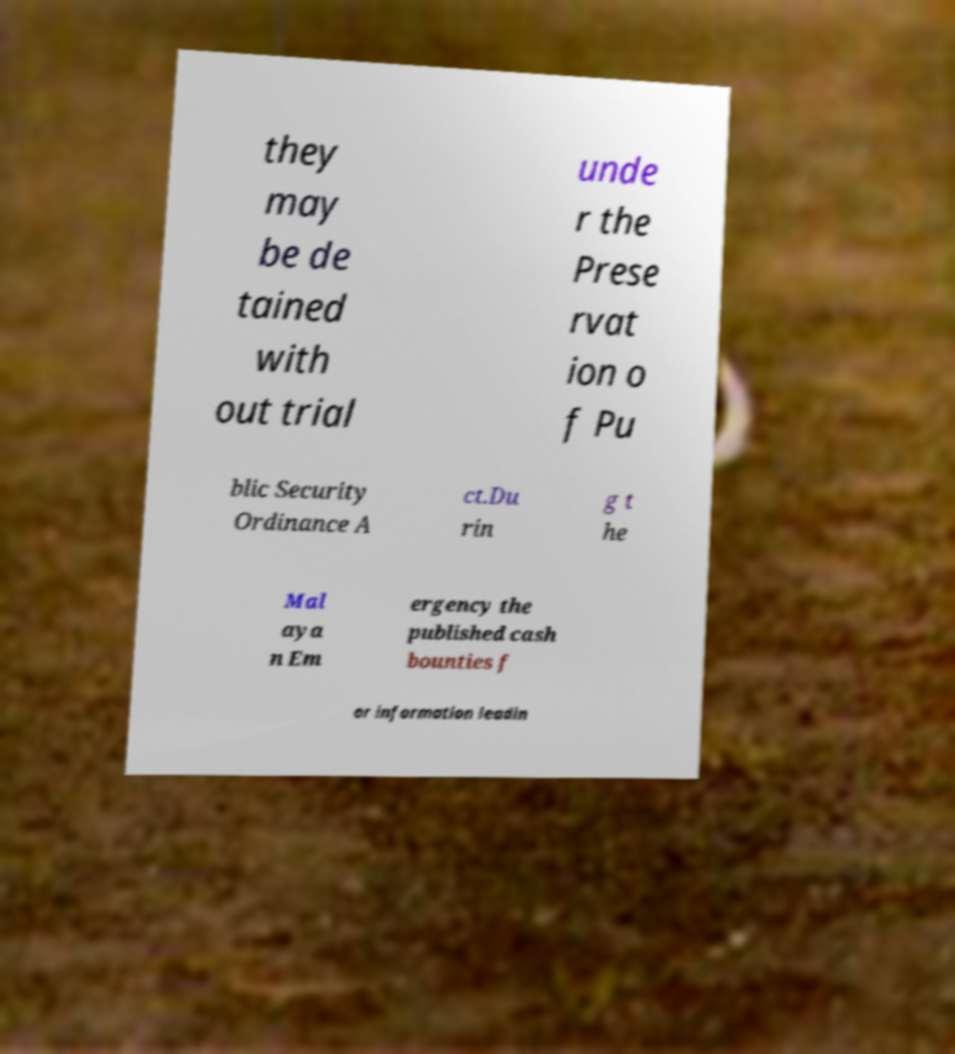Can you read and provide the text displayed in the image?This photo seems to have some interesting text. Can you extract and type it out for me? they may be de tained with out trial unde r the Prese rvat ion o f Pu blic Security Ordinance A ct.Du rin g t he Mal aya n Em ergency the published cash bounties f or information leadin 